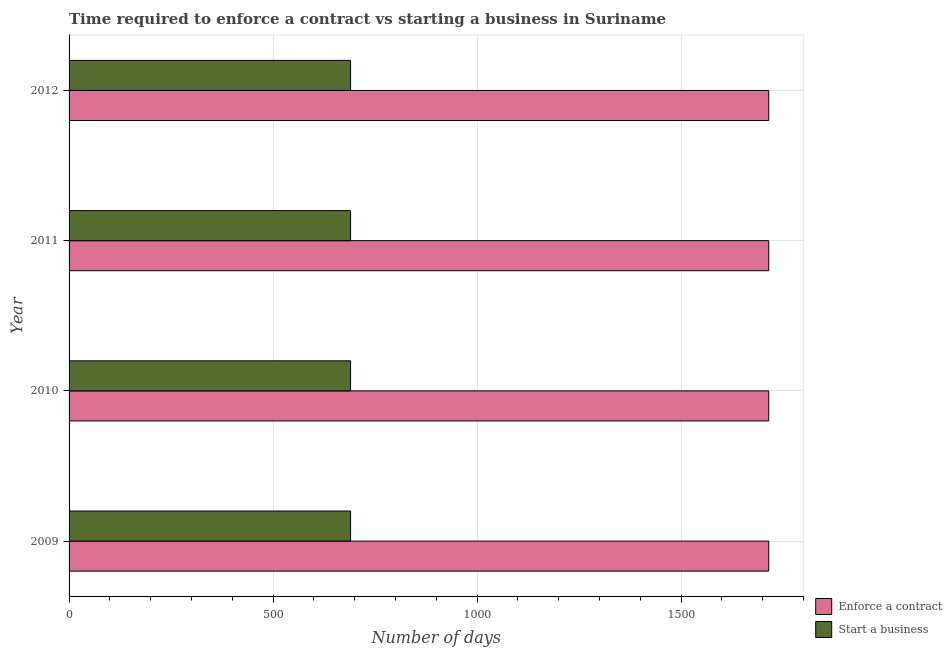How many groups of bars are there?
Your response must be concise. 4. Are the number of bars on each tick of the Y-axis equal?
Keep it short and to the point. Yes. How many bars are there on the 3rd tick from the top?
Offer a terse response. 2. How many bars are there on the 4th tick from the bottom?
Give a very brief answer. 2. What is the label of the 1st group of bars from the top?
Your answer should be very brief. 2012. In how many cases, is the number of bars for a given year not equal to the number of legend labels?
Offer a very short reply. 0. What is the number of days to enforece a contract in 2012?
Provide a succinct answer. 1715. Across all years, what is the maximum number of days to enforece a contract?
Your answer should be compact. 1715. Across all years, what is the minimum number of days to enforece a contract?
Ensure brevity in your answer.  1715. In which year was the number of days to start a business minimum?
Ensure brevity in your answer.  2009. What is the total number of days to enforece a contract in the graph?
Ensure brevity in your answer.  6860. What is the difference between the number of days to start a business in 2009 and that in 2012?
Ensure brevity in your answer.  0. What is the difference between the number of days to enforece a contract in 2012 and the number of days to start a business in 2011?
Offer a very short reply. 1025. What is the average number of days to start a business per year?
Your response must be concise. 690. In the year 2009, what is the difference between the number of days to start a business and number of days to enforece a contract?
Offer a terse response. -1025. What is the ratio of the number of days to start a business in 2010 to that in 2012?
Your response must be concise. 1. Is the number of days to enforece a contract in 2011 less than that in 2012?
Keep it short and to the point. No. What is the difference between the highest and the second highest number of days to start a business?
Your answer should be compact. 0. In how many years, is the number of days to start a business greater than the average number of days to start a business taken over all years?
Keep it short and to the point. 0. Is the sum of the number of days to start a business in 2009 and 2011 greater than the maximum number of days to enforece a contract across all years?
Provide a short and direct response. No. What does the 1st bar from the top in 2012 represents?
Your answer should be very brief. Start a business. What does the 2nd bar from the bottom in 2012 represents?
Your answer should be compact. Start a business. How many bars are there?
Give a very brief answer. 8. How many years are there in the graph?
Your answer should be compact. 4. What is the difference between two consecutive major ticks on the X-axis?
Keep it short and to the point. 500. Are the values on the major ticks of X-axis written in scientific E-notation?
Your answer should be very brief. No. Does the graph contain grids?
Provide a short and direct response. Yes. Where does the legend appear in the graph?
Provide a short and direct response. Bottom right. What is the title of the graph?
Give a very brief answer. Time required to enforce a contract vs starting a business in Suriname. What is the label or title of the X-axis?
Make the answer very short. Number of days. What is the label or title of the Y-axis?
Make the answer very short. Year. What is the Number of days of Enforce a contract in 2009?
Offer a very short reply. 1715. What is the Number of days of Start a business in 2009?
Keep it short and to the point. 690. What is the Number of days of Enforce a contract in 2010?
Your answer should be compact. 1715. What is the Number of days in Start a business in 2010?
Give a very brief answer. 690. What is the Number of days in Enforce a contract in 2011?
Keep it short and to the point. 1715. What is the Number of days of Start a business in 2011?
Your answer should be very brief. 690. What is the Number of days in Enforce a contract in 2012?
Make the answer very short. 1715. What is the Number of days of Start a business in 2012?
Make the answer very short. 690. Across all years, what is the maximum Number of days of Enforce a contract?
Provide a short and direct response. 1715. Across all years, what is the maximum Number of days of Start a business?
Make the answer very short. 690. Across all years, what is the minimum Number of days in Enforce a contract?
Give a very brief answer. 1715. Across all years, what is the minimum Number of days of Start a business?
Offer a very short reply. 690. What is the total Number of days of Enforce a contract in the graph?
Make the answer very short. 6860. What is the total Number of days in Start a business in the graph?
Provide a succinct answer. 2760. What is the difference between the Number of days of Enforce a contract in 2009 and that in 2011?
Ensure brevity in your answer.  0. What is the difference between the Number of days in Start a business in 2009 and that in 2011?
Your answer should be very brief. 0. What is the difference between the Number of days of Start a business in 2009 and that in 2012?
Your answer should be compact. 0. What is the difference between the Number of days of Enforce a contract in 2010 and that in 2011?
Ensure brevity in your answer.  0. What is the difference between the Number of days in Start a business in 2011 and that in 2012?
Offer a terse response. 0. What is the difference between the Number of days of Enforce a contract in 2009 and the Number of days of Start a business in 2010?
Your answer should be compact. 1025. What is the difference between the Number of days in Enforce a contract in 2009 and the Number of days in Start a business in 2011?
Your response must be concise. 1025. What is the difference between the Number of days in Enforce a contract in 2009 and the Number of days in Start a business in 2012?
Give a very brief answer. 1025. What is the difference between the Number of days of Enforce a contract in 2010 and the Number of days of Start a business in 2011?
Offer a very short reply. 1025. What is the difference between the Number of days in Enforce a contract in 2010 and the Number of days in Start a business in 2012?
Ensure brevity in your answer.  1025. What is the difference between the Number of days in Enforce a contract in 2011 and the Number of days in Start a business in 2012?
Your answer should be very brief. 1025. What is the average Number of days in Enforce a contract per year?
Provide a short and direct response. 1715. What is the average Number of days of Start a business per year?
Keep it short and to the point. 690. In the year 2009, what is the difference between the Number of days in Enforce a contract and Number of days in Start a business?
Provide a short and direct response. 1025. In the year 2010, what is the difference between the Number of days in Enforce a contract and Number of days in Start a business?
Offer a very short reply. 1025. In the year 2011, what is the difference between the Number of days of Enforce a contract and Number of days of Start a business?
Provide a succinct answer. 1025. In the year 2012, what is the difference between the Number of days in Enforce a contract and Number of days in Start a business?
Provide a short and direct response. 1025. What is the ratio of the Number of days in Enforce a contract in 2009 to that in 2011?
Offer a very short reply. 1. What is the ratio of the Number of days in Start a business in 2009 to that in 2011?
Provide a short and direct response. 1. What is the ratio of the Number of days in Enforce a contract in 2009 to that in 2012?
Keep it short and to the point. 1. What is the ratio of the Number of days of Start a business in 2009 to that in 2012?
Your answer should be compact. 1. What is the ratio of the Number of days of Enforce a contract in 2010 to that in 2011?
Your answer should be compact. 1. What is the ratio of the Number of days of Enforce a contract in 2010 to that in 2012?
Your answer should be very brief. 1. What is the ratio of the Number of days in Enforce a contract in 2011 to that in 2012?
Make the answer very short. 1. What is the difference between the highest and the lowest Number of days of Enforce a contract?
Make the answer very short. 0. 